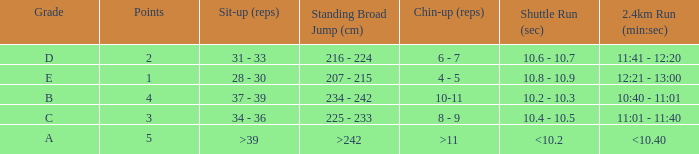Tell me the 2.4km run for points less than 2 12:21 - 13:00. 